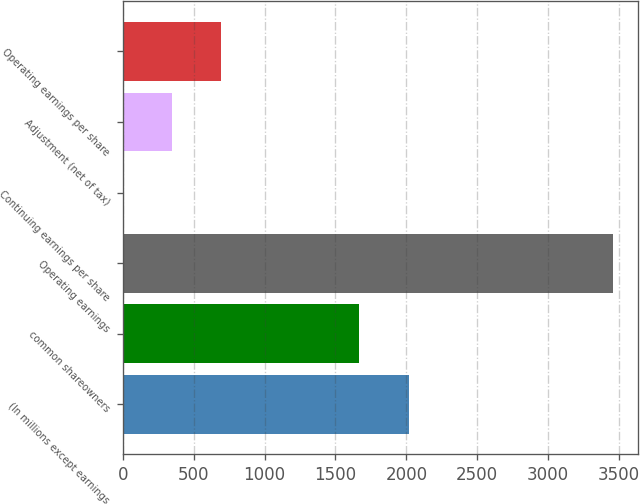<chart> <loc_0><loc_0><loc_500><loc_500><bar_chart><fcel>(In millions except earnings<fcel>common shareowners<fcel>Operating earnings<fcel>Continuing earnings per share<fcel>Adjustment (net of tax)<fcel>Operating earnings per share<nl><fcel>2015<fcel>1663<fcel>3460<fcel>0.17<fcel>346.15<fcel>692.13<nl></chart> 